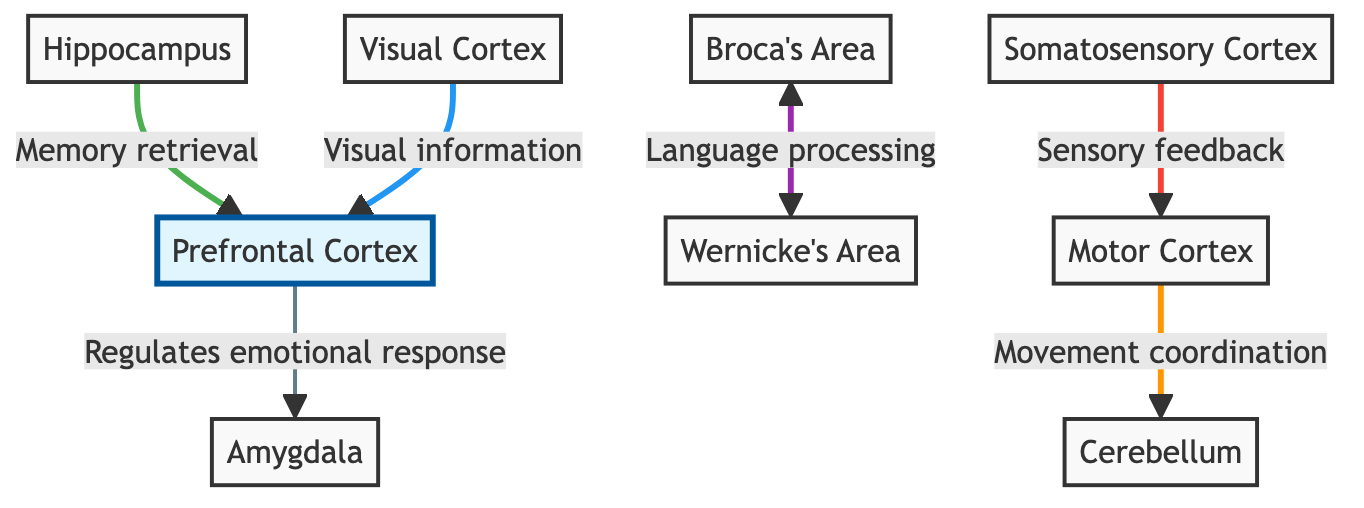What is the major role of the prefrontal cortex? The prefrontal cortex is highlighted in the diagram, indicating its importance. It regulates emotional responses, as indicated by the arrow pointing to the amygdala.
Answer: Regulates emotional response Which area is associated with memory retrieval? The hippocampus is connected to the prefrontal cortex with an arrow labeled 'Memory retrieval.' Therefore, this area is responsible for that function.
Answer: Hippocampus How many major functional areas are represented in the diagram? The diagram lists seven major areas: Prefrontal Cortex, Hippocampus, Amygdala, Broca's Area, Wernicke's Area, Motor Cortex, Somatosensory Cortex, Visual Cortex, and Cerebellum. So, the total is seven.
Answer: 7 What pathway is involved in language processing? The diagram shows a bidirectional arrow between Broca's Area and Wernicke's Area, indicating a connection for language processing.
Answer: Broca's Area and Wernicke's Area What area coordinates movement? The Motor Cortex is shown to have a direct connection to the Cerebellum for movement coordination. Thus, it's the area responsible for that activity.
Answer: Motor Cortex Which area receives visual information? The Visual Cortex is connected to the Prefrontal Cortex with an arrow that specifies it sends visual information, indicating that it is the source of this type of information.
Answer: Visual Cortex Which two areas are directly related to sensory feedback and movements? The diagram specifies that the Somatosensory Cortex connects to the Motor Cortex, indicating that these two areas are directly involved in sensory feedback and movement coordination.
Answer: Somatosensory Cortex and Motor Cortex What is the link style between the Prefrontal Cortex and the Amygdala? The diagram indicates this relationship with a stroke width of 3px and a color indicating a specific function, which can help identify its importance. Specifically, it's highlighted with a green stroke.
Answer: Stroke width: 3px (green) What neural pathway connects visual information to emotional response? The flowchart shows an arrow leading from the Visual Cortex to the Prefrontal Cortex. Since the Prefrontal Cortex is tied to emotional responses, this pathway connects visual information to emotional processing.
Answer: Visual Cortex to Prefrontal Cortex 